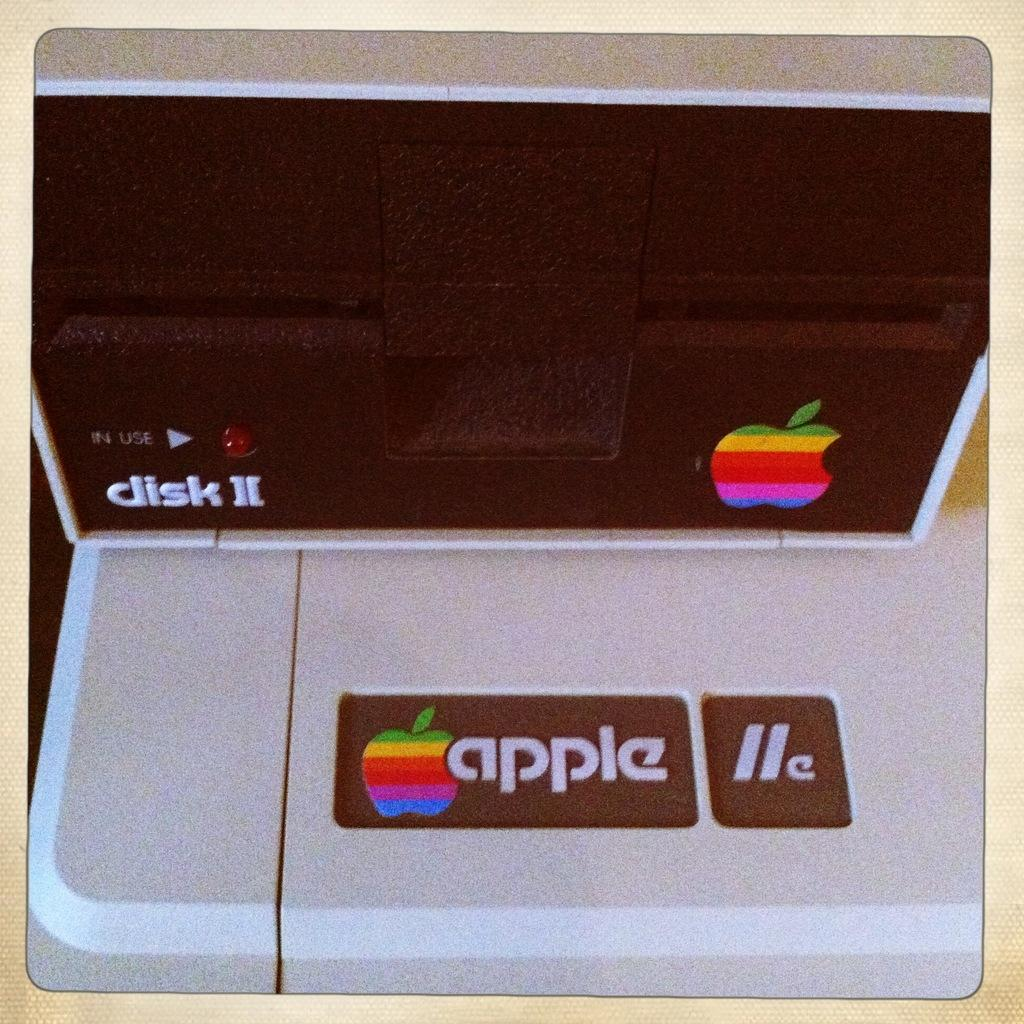<image>
Present a compact description of the photo's key features. An APPLE brand item is sitting on a table which appears to be a place to insert discs into a computer as an add on. 